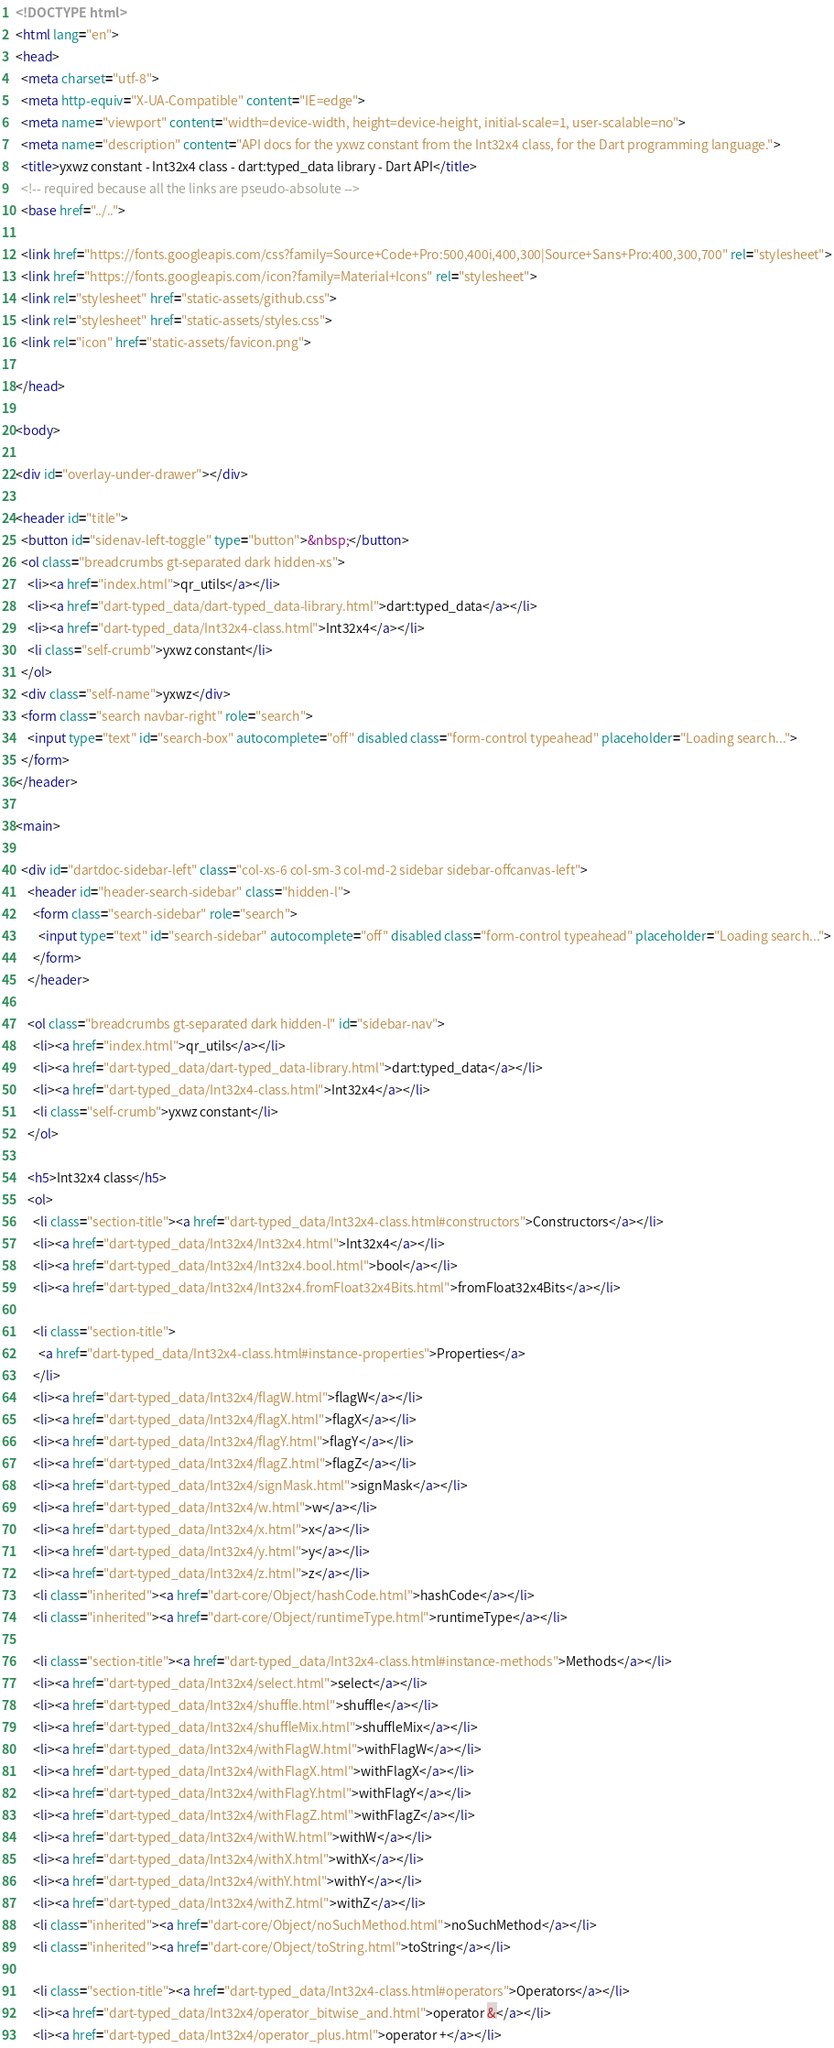<code> <loc_0><loc_0><loc_500><loc_500><_HTML_><!DOCTYPE html>
<html lang="en">
<head>
  <meta charset="utf-8">
  <meta http-equiv="X-UA-Compatible" content="IE=edge">
  <meta name="viewport" content="width=device-width, height=device-height, initial-scale=1, user-scalable=no">
  <meta name="description" content="API docs for the yxwz constant from the Int32x4 class, for the Dart programming language.">
  <title>yxwz constant - Int32x4 class - dart:typed_data library - Dart API</title>
  <!-- required because all the links are pseudo-absolute -->
  <base href="../..">

  <link href="https://fonts.googleapis.com/css?family=Source+Code+Pro:500,400i,400,300|Source+Sans+Pro:400,300,700" rel="stylesheet">
  <link href="https://fonts.googleapis.com/icon?family=Material+Icons" rel="stylesheet">
  <link rel="stylesheet" href="static-assets/github.css">
  <link rel="stylesheet" href="static-assets/styles.css">
  <link rel="icon" href="static-assets/favicon.png">
  
</head>

<body>

<div id="overlay-under-drawer"></div>

<header id="title">
  <button id="sidenav-left-toggle" type="button">&nbsp;</button>
  <ol class="breadcrumbs gt-separated dark hidden-xs">
    <li><a href="index.html">qr_utils</a></li>
    <li><a href="dart-typed_data/dart-typed_data-library.html">dart:typed_data</a></li>
    <li><a href="dart-typed_data/Int32x4-class.html">Int32x4</a></li>
    <li class="self-crumb">yxwz constant</li>
  </ol>
  <div class="self-name">yxwz</div>
  <form class="search navbar-right" role="search">
    <input type="text" id="search-box" autocomplete="off" disabled class="form-control typeahead" placeholder="Loading search...">
  </form>
</header>

<main>

  <div id="dartdoc-sidebar-left" class="col-xs-6 col-sm-3 col-md-2 sidebar sidebar-offcanvas-left">
    <header id="header-search-sidebar" class="hidden-l">
      <form class="search-sidebar" role="search">
        <input type="text" id="search-sidebar" autocomplete="off" disabled class="form-control typeahead" placeholder="Loading search...">
      </form>
    </header>
    
    <ol class="breadcrumbs gt-separated dark hidden-l" id="sidebar-nav">
      <li><a href="index.html">qr_utils</a></li>
      <li><a href="dart-typed_data/dart-typed_data-library.html">dart:typed_data</a></li>
      <li><a href="dart-typed_data/Int32x4-class.html">Int32x4</a></li>
      <li class="self-crumb">yxwz constant</li>
    </ol>
    
    <h5>Int32x4 class</h5>
    <ol>
      <li class="section-title"><a href="dart-typed_data/Int32x4-class.html#constructors">Constructors</a></li>
      <li><a href="dart-typed_data/Int32x4/Int32x4.html">Int32x4</a></li>
      <li><a href="dart-typed_data/Int32x4/Int32x4.bool.html">bool</a></li>
      <li><a href="dart-typed_data/Int32x4/Int32x4.fromFloat32x4Bits.html">fromFloat32x4Bits</a></li>
    
      <li class="section-title">
        <a href="dart-typed_data/Int32x4-class.html#instance-properties">Properties</a>
      </li>
      <li><a href="dart-typed_data/Int32x4/flagW.html">flagW</a></li>
      <li><a href="dart-typed_data/Int32x4/flagX.html">flagX</a></li>
      <li><a href="dart-typed_data/Int32x4/flagY.html">flagY</a></li>
      <li><a href="dart-typed_data/Int32x4/flagZ.html">flagZ</a></li>
      <li><a href="dart-typed_data/Int32x4/signMask.html">signMask</a></li>
      <li><a href="dart-typed_data/Int32x4/w.html">w</a></li>
      <li><a href="dart-typed_data/Int32x4/x.html">x</a></li>
      <li><a href="dart-typed_data/Int32x4/y.html">y</a></li>
      <li><a href="dart-typed_data/Int32x4/z.html">z</a></li>
      <li class="inherited"><a href="dart-core/Object/hashCode.html">hashCode</a></li>
      <li class="inherited"><a href="dart-core/Object/runtimeType.html">runtimeType</a></li>
    
      <li class="section-title"><a href="dart-typed_data/Int32x4-class.html#instance-methods">Methods</a></li>
      <li><a href="dart-typed_data/Int32x4/select.html">select</a></li>
      <li><a href="dart-typed_data/Int32x4/shuffle.html">shuffle</a></li>
      <li><a href="dart-typed_data/Int32x4/shuffleMix.html">shuffleMix</a></li>
      <li><a href="dart-typed_data/Int32x4/withFlagW.html">withFlagW</a></li>
      <li><a href="dart-typed_data/Int32x4/withFlagX.html">withFlagX</a></li>
      <li><a href="dart-typed_data/Int32x4/withFlagY.html">withFlagY</a></li>
      <li><a href="dart-typed_data/Int32x4/withFlagZ.html">withFlagZ</a></li>
      <li><a href="dart-typed_data/Int32x4/withW.html">withW</a></li>
      <li><a href="dart-typed_data/Int32x4/withX.html">withX</a></li>
      <li><a href="dart-typed_data/Int32x4/withY.html">withY</a></li>
      <li><a href="dart-typed_data/Int32x4/withZ.html">withZ</a></li>
      <li class="inherited"><a href="dart-core/Object/noSuchMethod.html">noSuchMethod</a></li>
      <li class="inherited"><a href="dart-core/Object/toString.html">toString</a></li>
    
      <li class="section-title"><a href="dart-typed_data/Int32x4-class.html#operators">Operators</a></li>
      <li><a href="dart-typed_data/Int32x4/operator_bitwise_and.html">operator &</a></li>
      <li><a href="dart-typed_data/Int32x4/operator_plus.html">operator +</a></li></code> 